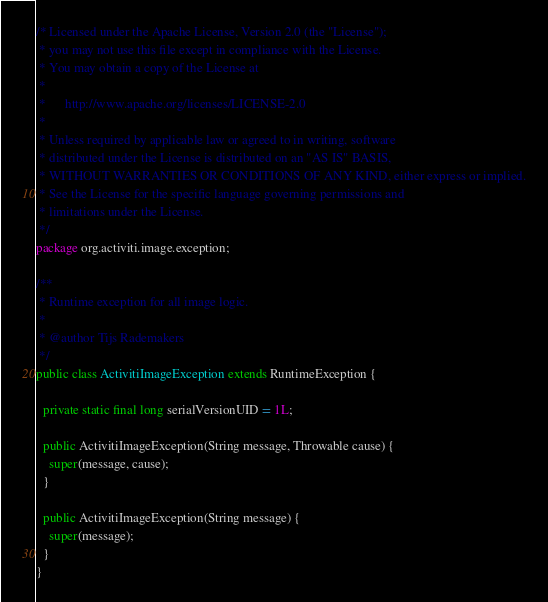<code> <loc_0><loc_0><loc_500><loc_500><_Java_>/* Licensed under the Apache License, Version 2.0 (the "License");
 * you may not use this file except in compliance with the License.
 * You may obtain a copy of the License at
 * 
 *      http://www.apache.org/licenses/LICENSE-2.0
 * 
 * Unless required by applicable law or agreed to in writing, software
 * distributed under the License is distributed on an "AS IS" BASIS,
 * WITHOUT WARRANTIES OR CONDITIONS OF ANY KIND, either express or implied.
 * See the License for the specific language governing permissions and
 * limitations under the License.
 */
package org.activiti.image.exception;

/**
 * Runtime exception for all image logic.
 * 
 * @author Tijs Rademakers
 */
public class ActivitiImageException extends RuntimeException {

  private static final long serialVersionUID = 1L;

  public ActivitiImageException(String message, Throwable cause) {
    super(message, cause);
  }

  public ActivitiImageException(String message) {
    super(message);
  }
}
</code> 